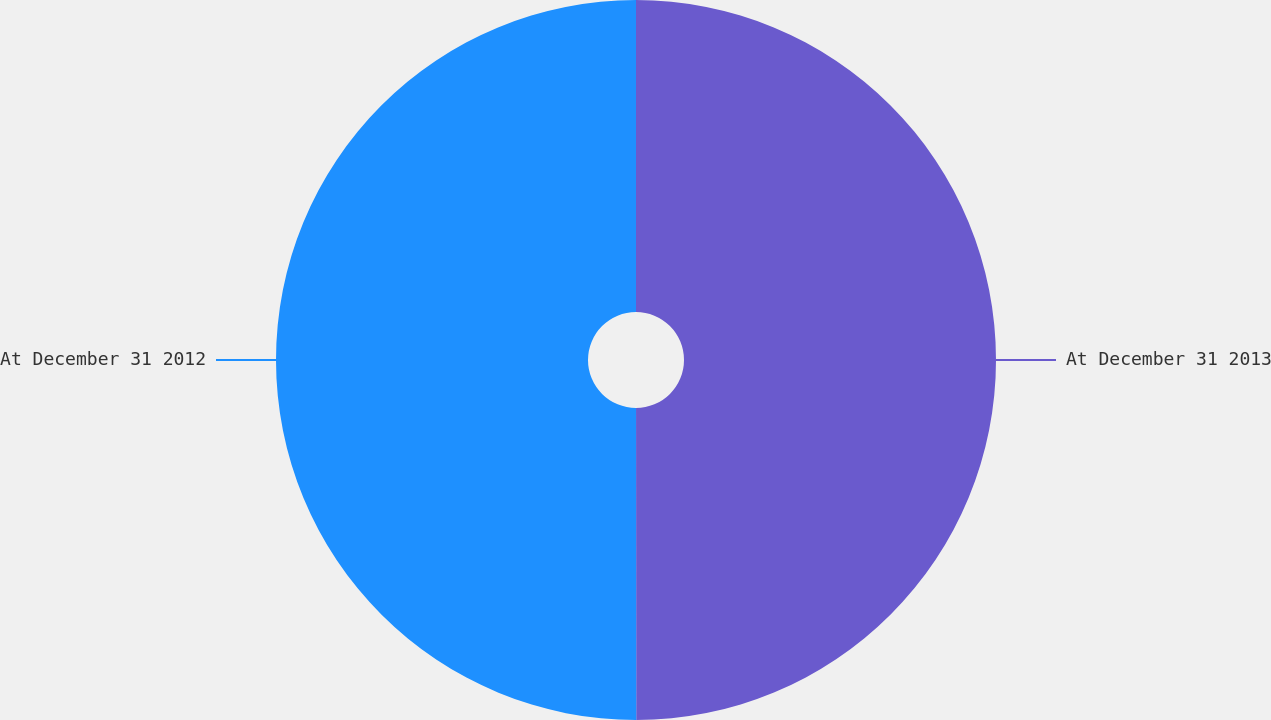Convert chart. <chart><loc_0><loc_0><loc_500><loc_500><pie_chart><fcel>At December 31 2013<fcel>At December 31 2012<nl><fcel>49.99%<fcel>50.01%<nl></chart> 